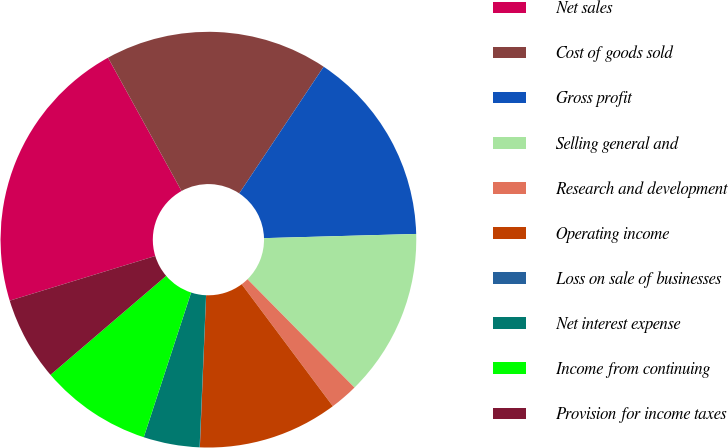<chart> <loc_0><loc_0><loc_500><loc_500><pie_chart><fcel>Net sales<fcel>Cost of goods sold<fcel>Gross profit<fcel>Selling general and<fcel>Research and development<fcel>Operating income<fcel>Loss on sale of businesses<fcel>Net interest expense<fcel>Income from continuing<fcel>Provision for income taxes<nl><fcel>21.72%<fcel>17.38%<fcel>15.21%<fcel>13.04%<fcel>2.19%<fcel>10.87%<fcel>0.02%<fcel>4.36%<fcel>8.7%<fcel>6.53%<nl></chart> 